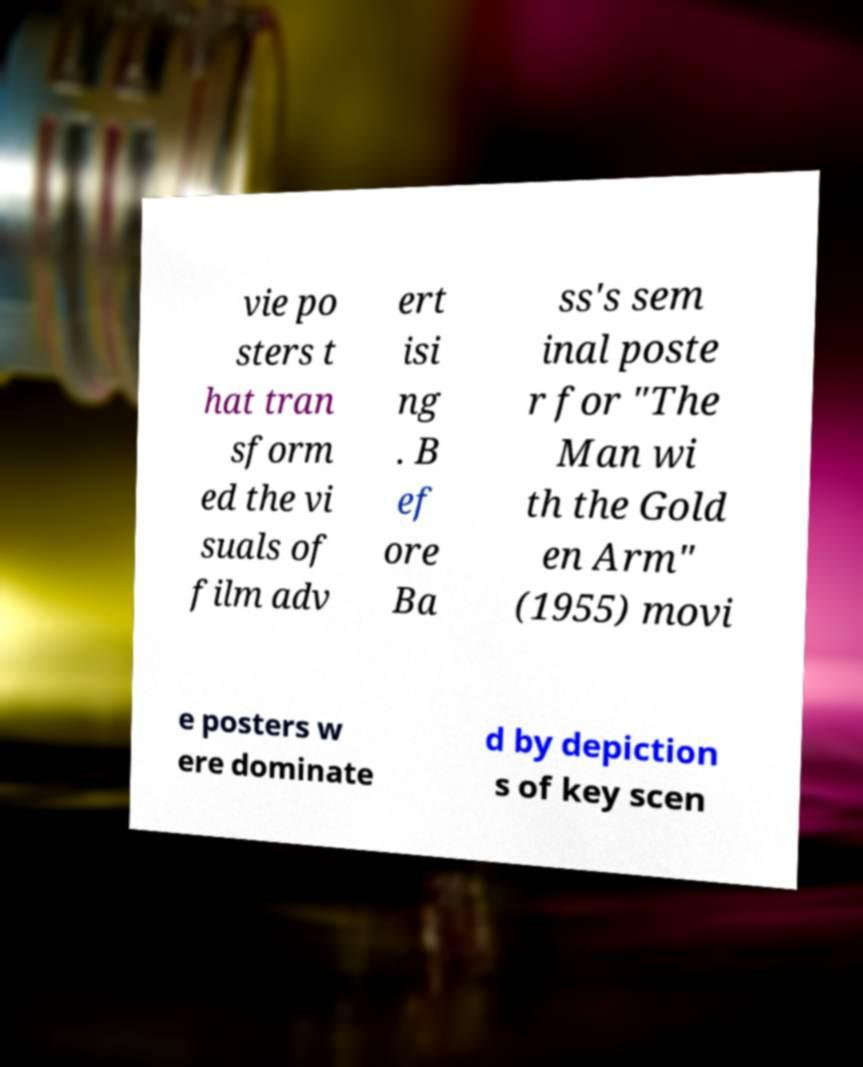Can you read and provide the text displayed in the image?This photo seems to have some interesting text. Can you extract and type it out for me? vie po sters t hat tran sform ed the vi suals of film adv ert isi ng . B ef ore Ba ss's sem inal poste r for "The Man wi th the Gold en Arm" (1955) movi e posters w ere dominate d by depiction s of key scen 